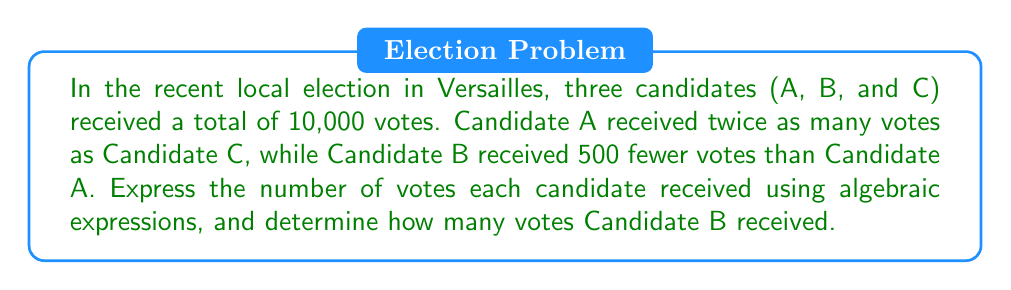Provide a solution to this math problem. Let's approach this step-by-step:

1) Let $x$ represent the number of votes Candidate C received.

2) Given the information, we can express the votes for each candidate:
   Candidate A: $2x$ (twice as many as C)
   Candidate B: $2x - 500$ (500 fewer than A)
   Candidate C: $x$

3) We know the total votes sum to 10,000. We can express this as an equation:
   $2x + (2x - 500) + x = 10000$

4) Simplify the left side of the equation:
   $5x - 500 = 10000$

5) Add 500 to both sides:
   $5x = 10500$

6) Divide both sides by 5:
   $x = 2100$

7) Now we know Candidate C received 2100 votes.

8) To find Candidate B's votes, we use the expression $2x - 500$:
   $2(2100) - 500 = 4200 - 500 = 3700$

Therefore, Candidate B received 3700 votes.
Answer: 3700 votes 